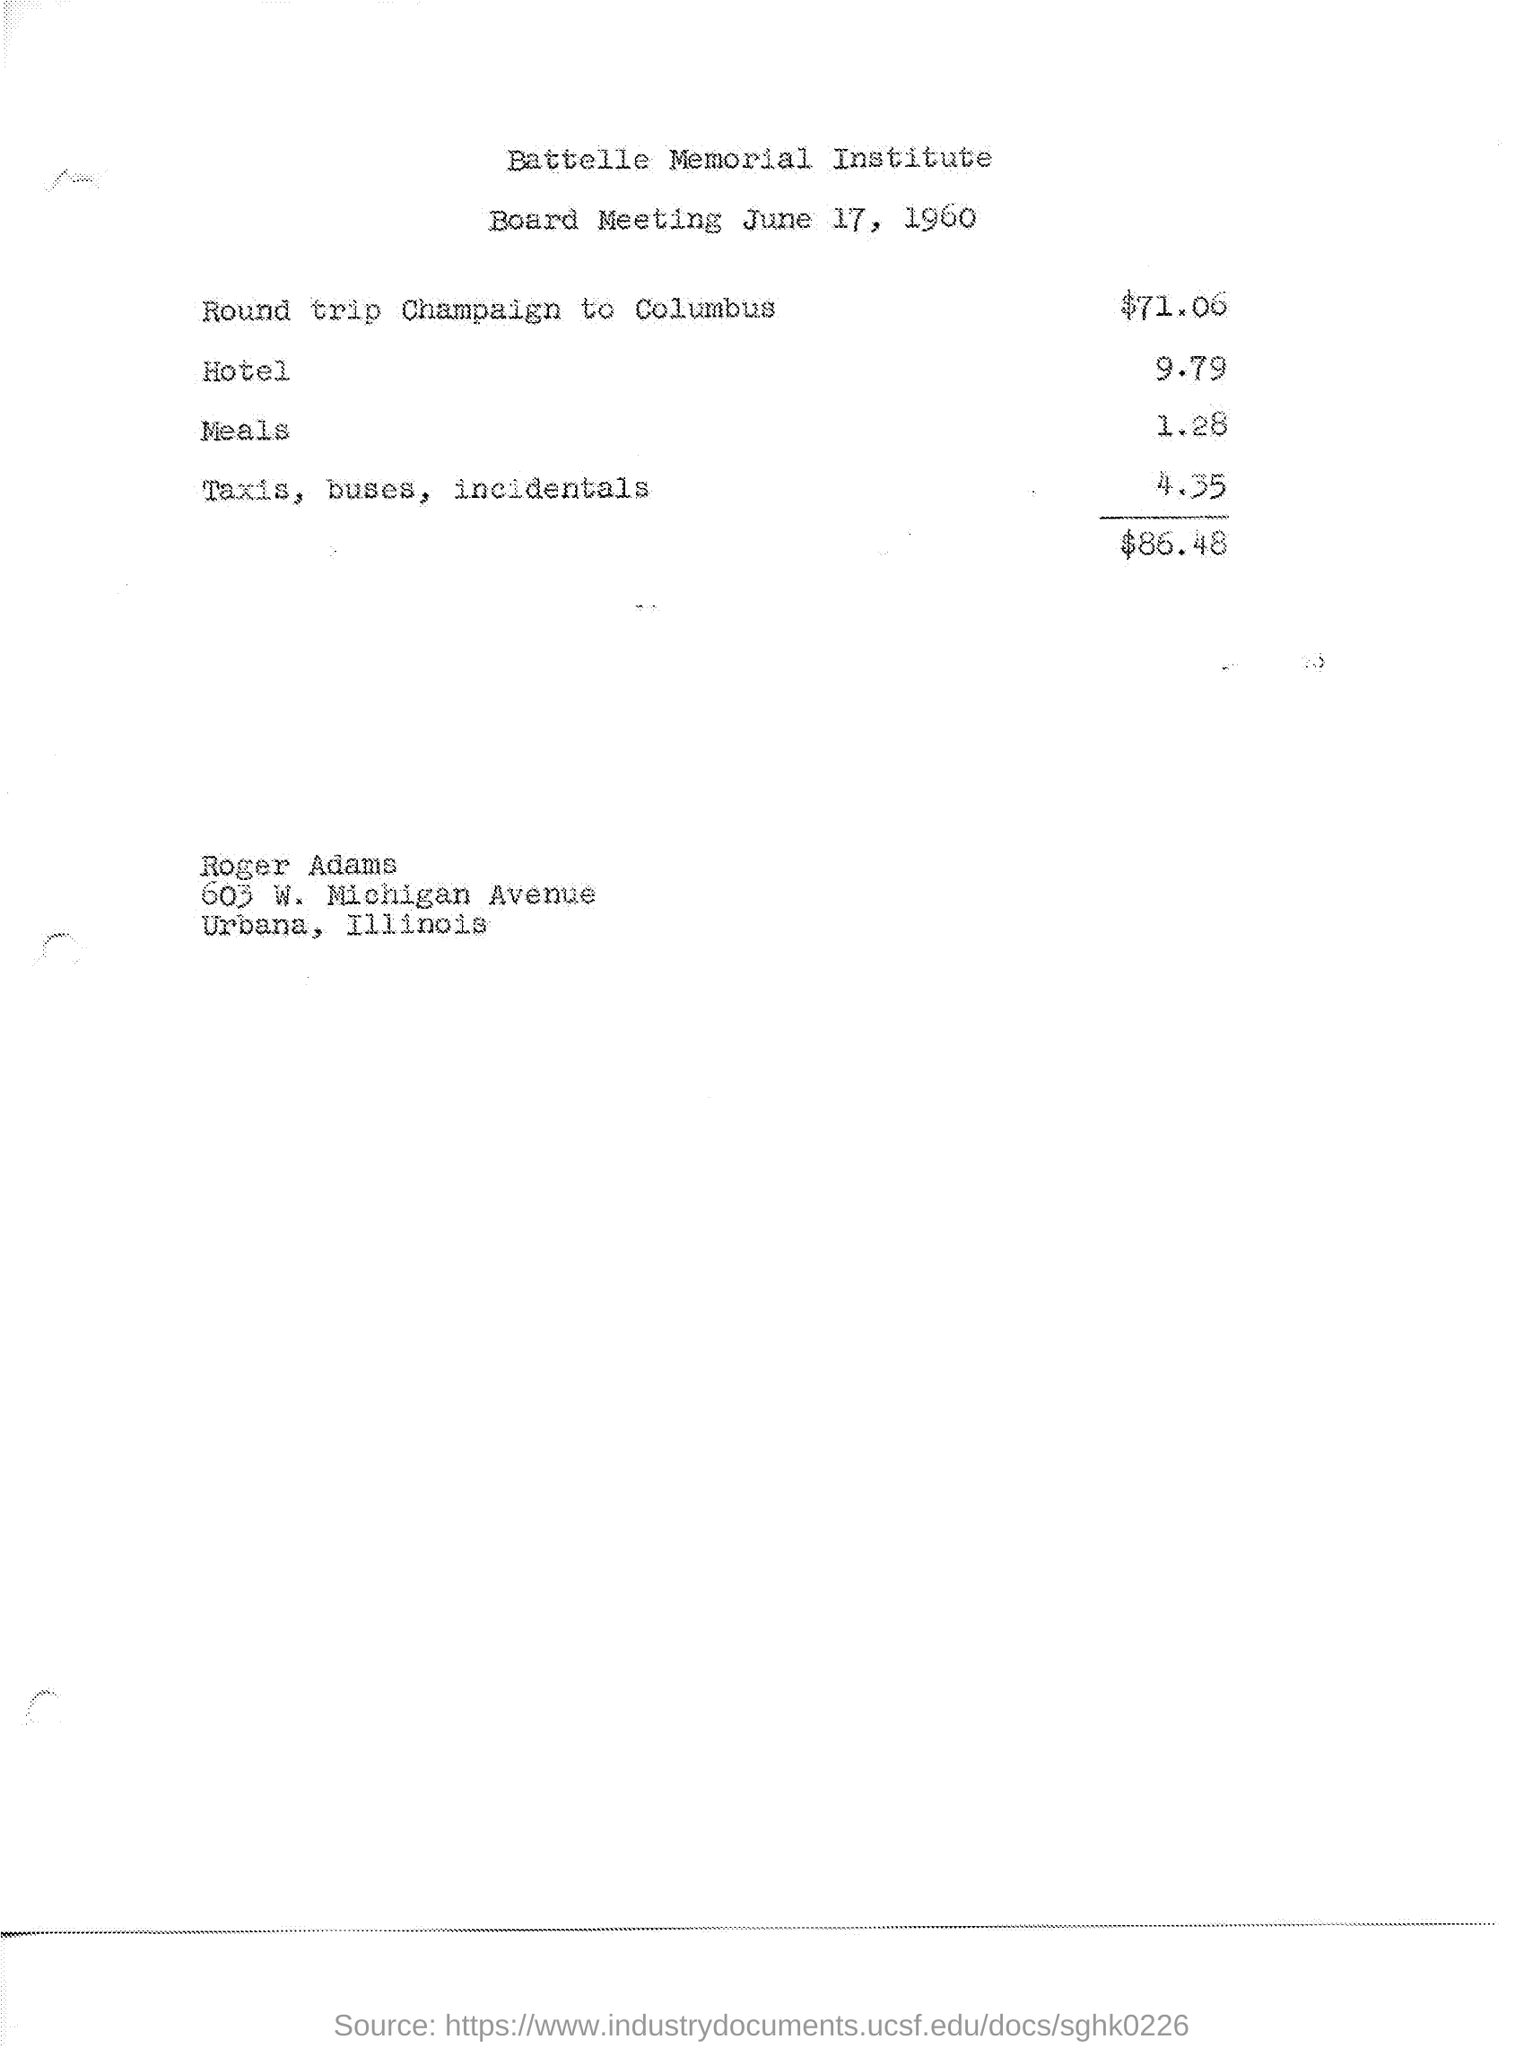When was the Board Meeting Held?
Provide a short and direct response. June 17, 1960. Whats the institute name?
Make the answer very short. Battelle Memorial Institute. 